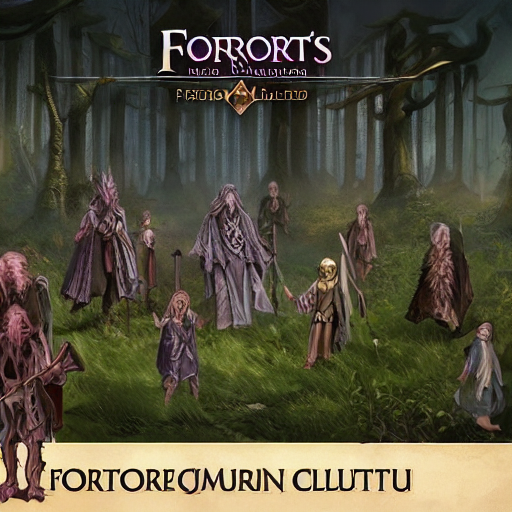Could you speculate on the symbolism of the attire worn by the figures in the image? The attire worn by the figures is rich with potential symbolism. The robes could represent a connection to nature and the earth, vital elements in many fantasy narratives involving magic. The intricate designs and symbols may represent rank, affiliation to different magical schools or disciplines, or even individual achievements. Hoods and masks add an element of anonymity or communion with higher, unseen forces. Each piece of clothing seems to have been chosen with care to reflect a deep narrative context within this fantasy scene. 